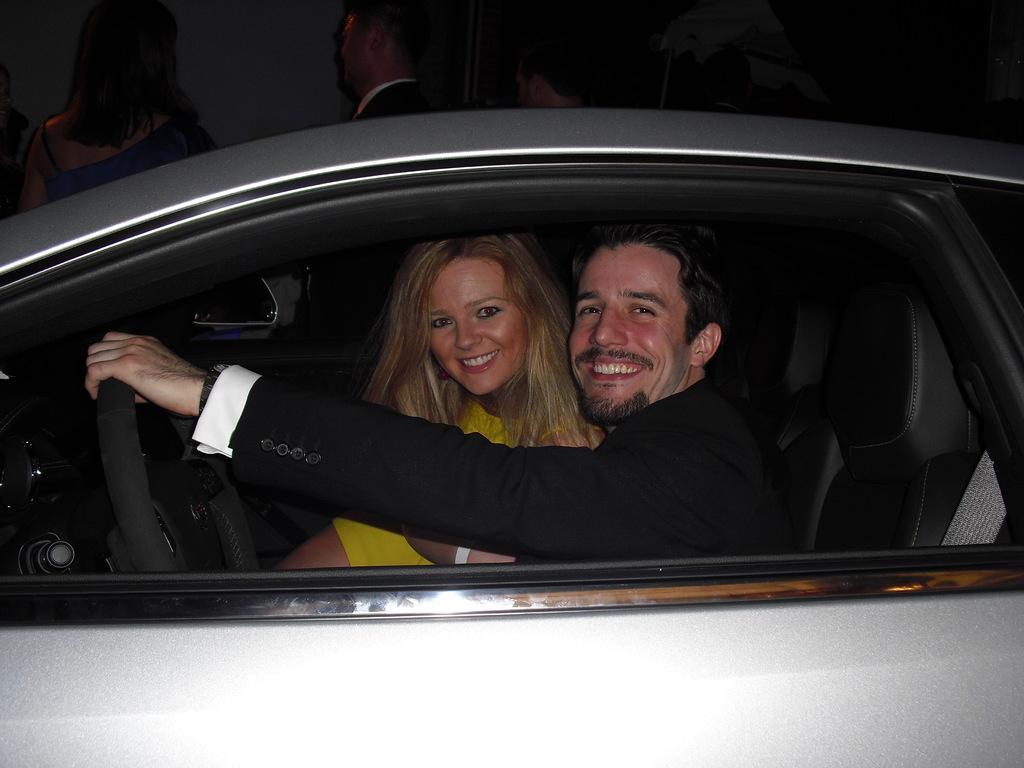In one or two sentences, can you explain what this image depicts? In this picture there are two people sitting in a car a man and women both of them are smiling and their steering wheel over here 